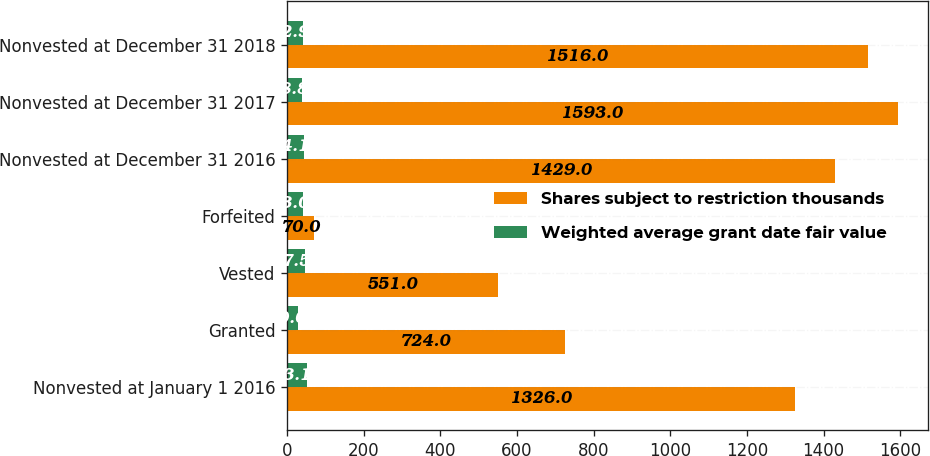<chart> <loc_0><loc_0><loc_500><loc_500><stacked_bar_chart><ecel><fcel>Nonvested at January 1 2016<fcel>Granted<fcel>Vested<fcel>Forfeited<fcel>Nonvested at December 31 2016<fcel>Nonvested at December 31 2017<fcel>Nonvested at December 31 2018<nl><fcel>Shares subject to restriction thousands<fcel>1326<fcel>724<fcel>551<fcel>70<fcel>1429<fcel>1593<fcel>1516<nl><fcel>Weighted average grant date fair value<fcel>53.18<fcel>30.07<fcel>47.55<fcel>43.05<fcel>44.12<fcel>38.86<fcel>42.97<nl></chart> 